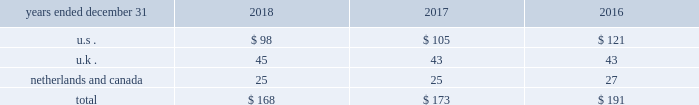( 3 ) refer to note 2 201csummary of significant accounting principles and practices 201d for further information .
13 .
Employee benefitsp y defined contribution savings plans aon maintains defined contribution savings plans for the benefit of its employees .
The expense recognized for these plans is included in compensation and benefits in the consolidated statements of income .
The expense for the significant plans in the u.s. , u.k. , netherlands and canada is as follows ( in millions ) : .
Pension and other postretirement benefits the company sponsors defined benefit pension and postretirement health and welfare plans that provide retirement , medical , and life insurance benefits .
The postretirement health care plans are contributory , with retiree contributions adjusted annually , and the aa life insurance and pension plans are generally noncontributory .
The significant u.s. , u.k. , netherlands and canadian pension plans are closed to new entrants. .
Considering the years 2016-2018 , what is the average expense for the significant plans in the u.k.? 
Rationale: it is the sum of all expense for the significant plans divided by three .
Computations: table_average(u.k ., none)
Answer: 43.66667. ( 3 ) refer to note 2 201csummary of significant accounting principles and practices 201d for further information .
13 .
Employee benefitsp y defined contribution savings plans aon maintains defined contribution savings plans for the benefit of its employees .
The expense recognized for these plans is included in compensation and benefits in the consolidated statements of income .
The expense for the significant plans in the u.s. , u.k. , netherlands and canada is as follows ( in millions ) : .
Pension and other postretirement benefits the company sponsors defined benefit pension and postretirement health and welfare plans that provide retirement , medical , and life insurance benefits .
The postretirement health care plans are contributory , with retiree contributions adjusted annually , and the aa life insurance and pension plans are generally noncontributory .
The significant u.s. , u.k. , netherlands and canadian pension plans are closed to new entrants. .
What was the change in the total benefits from 2017 to 2018 in millions? 
Rationale: the total benefits decreased by 5 million from 2017 to 2018
Computations: (168 - 173)
Answer: -5.0. ( 3 ) refer to note 2 201csummary of significant accounting principles and practices 201d for further information .
13 .
Employee benefitsp y defined contribution savings plans aon maintains defined contribution savings plans for the benefit of its employees .
The expense recognized for these plans is included in compensation and benefits in the consolidated statements of income .
The expense for the significant plans in the u.s. , u.k. , netherlands and canada is as follows ( in millions ) : .
Pension and other postretirement benefits the company sponsors defined benefit pension and postretirement health and welfare plans that provide retirement , medical , and life insurance benefits .
The postretirement health care plans are contributory , with retiree contributions adjusted annually , and the aa life insurance and pension plans are generally noncontributory .
The significant u.s. , u.k. , netherlands and canadian pension plans are closed to new entrants. .
Considering the years 2016-2018 , what is the average expense for the significant plans in the u.s.? 
Rationale: it is the sum of all expenses for the significant plans divided by three .
Computations: table_average(u.s ., none)
Answer: 108.0. 